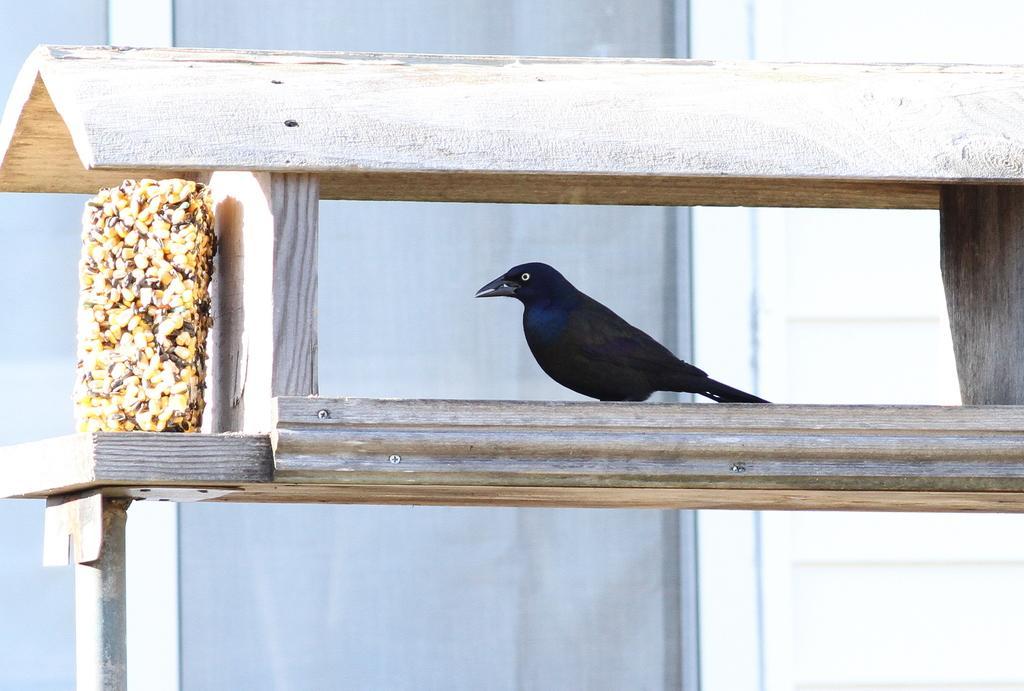Could you give a brief overview of what you see in this image? There is a crow inside a wooden structure in the foreground area of the image, it seems like a window in the background. 